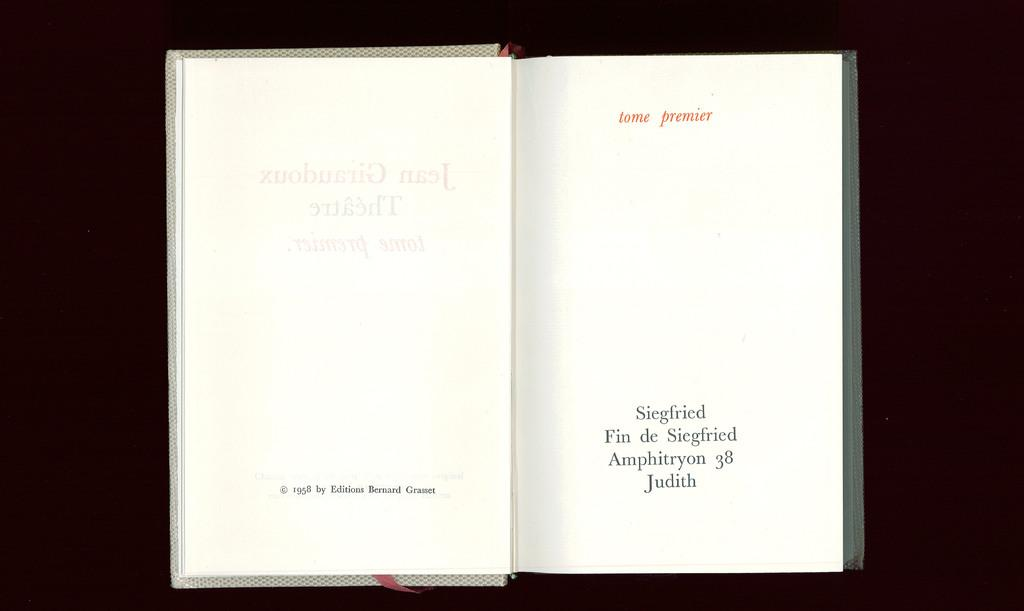Provide a one-sentence caption for the provided image. an open book titled Tome Premier and copyrighted in 1958. 